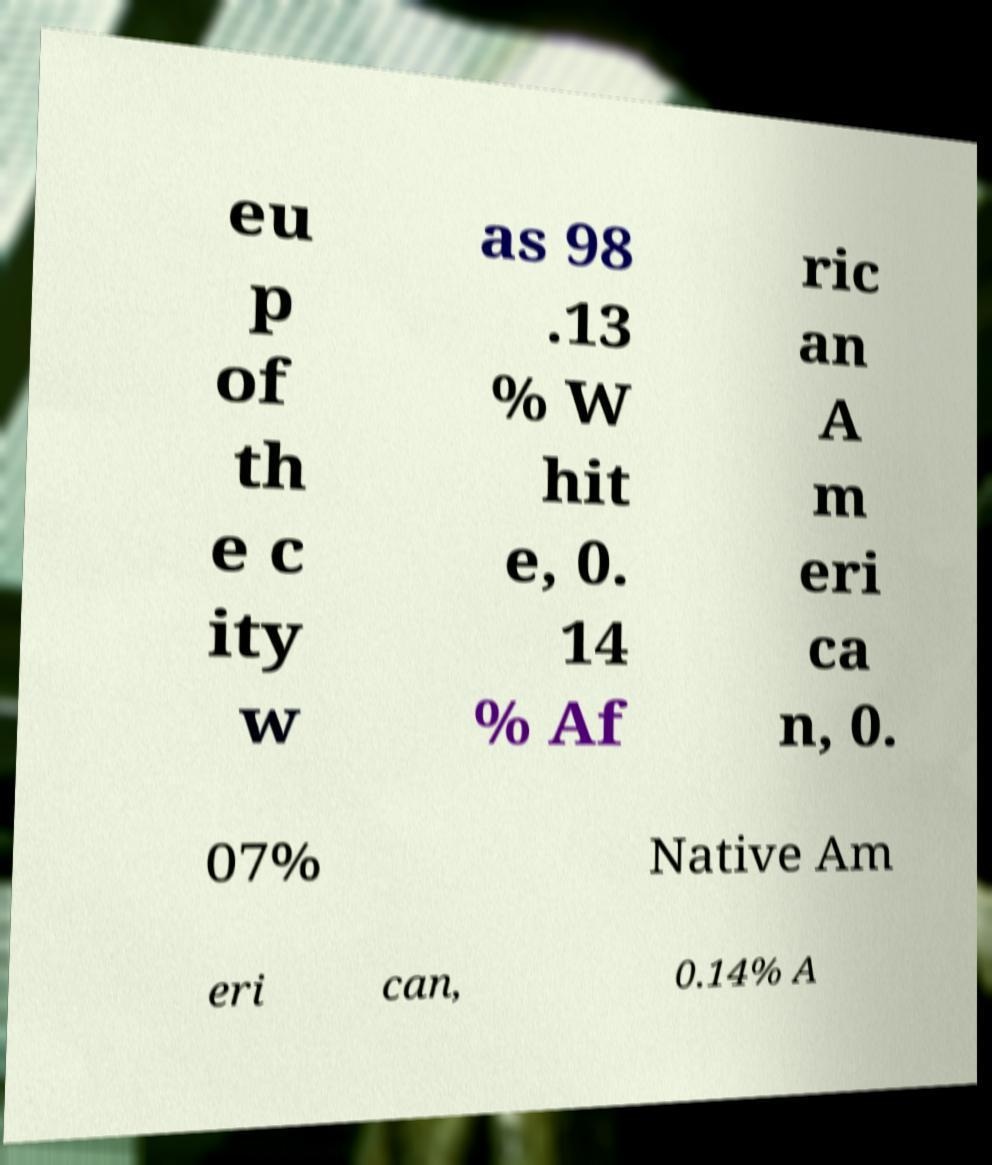Can you accurately transcribe the text from the provided image for me? eu p of th e c ity w as 98 .13 % W hit e, 0. 14 % Af ric an A m eri ca n, 0. 07% Native Am eri can, 0.14% A 